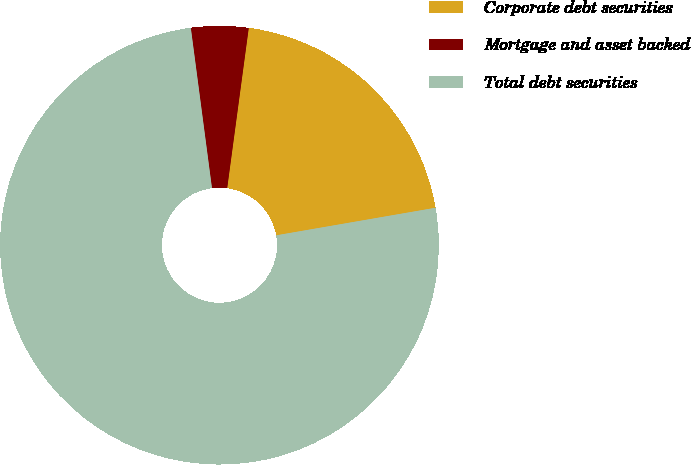Convert chart. <chart><loc_0><loc_0><loc_500><loc_500><pie_chart><fcel>Corporate debt securities<fcel>Mortgage and asset backed<fcel>Total debt securities<nl><fcel>20.14%<fcel>4.22%<fcel>75.63%<nl></chart> 